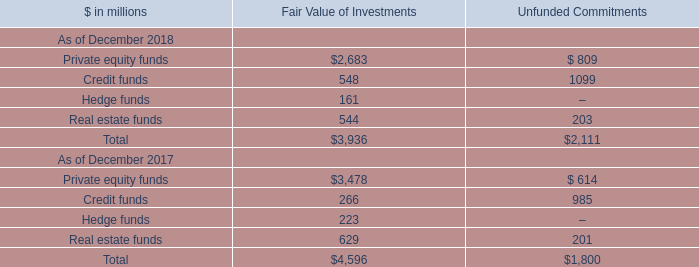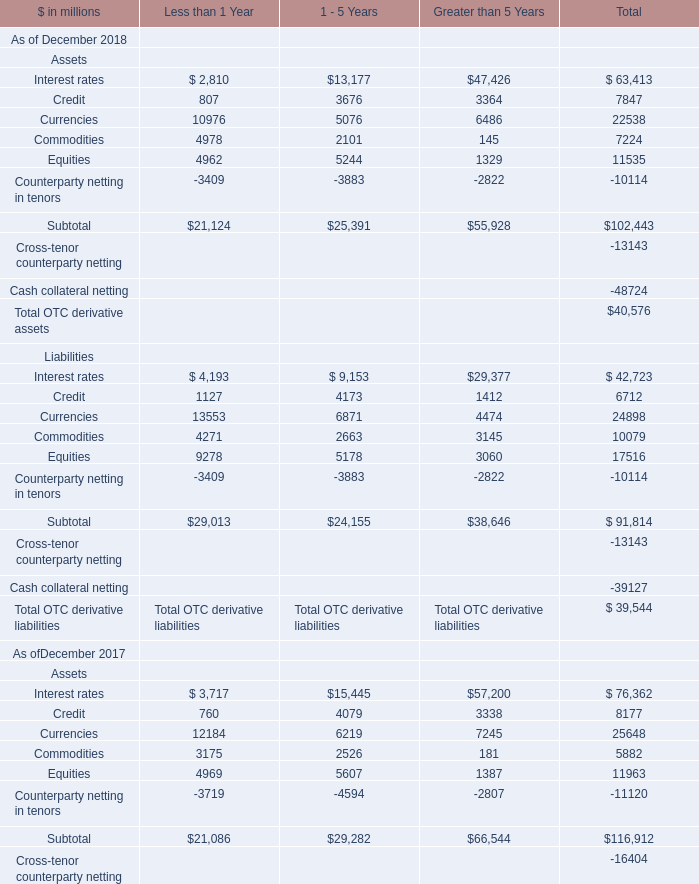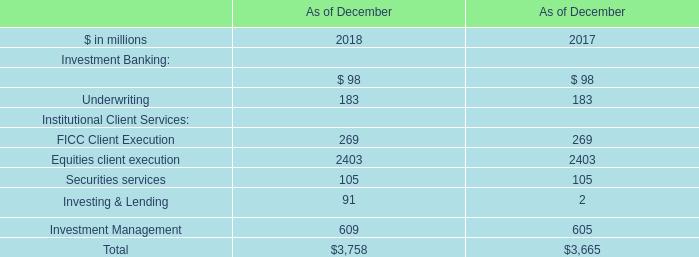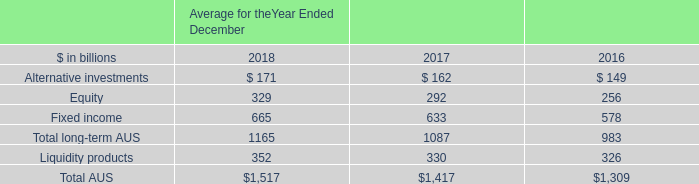what are the net revenues in investment management in 2016 , in billions? 
Computations: (6.22 / (1 + 7%))
Answer: 5.81308. 